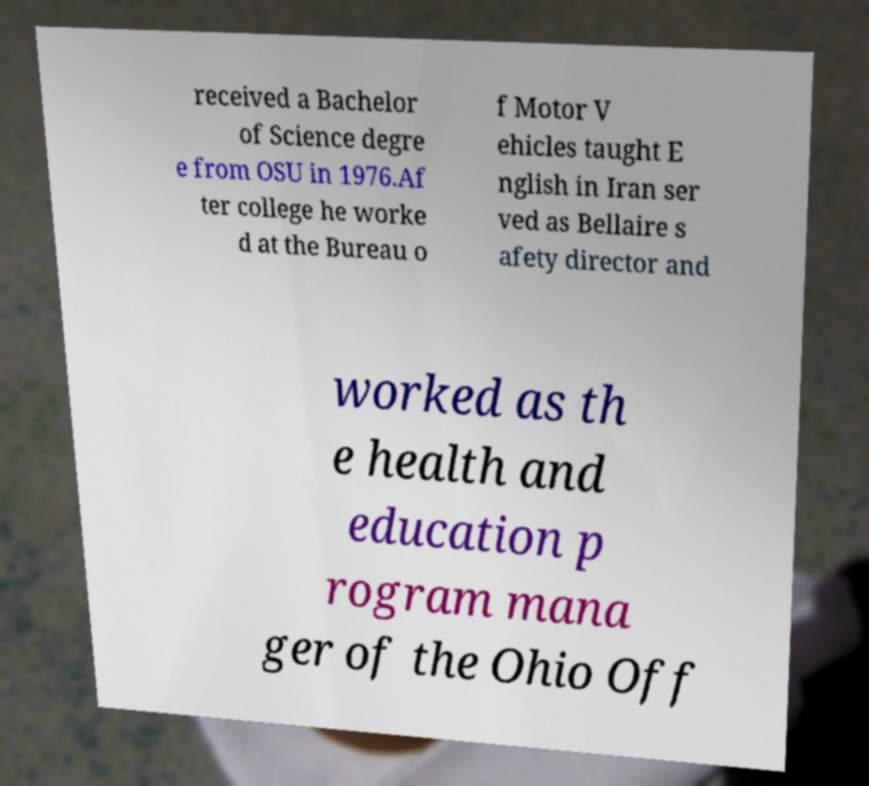Could you assist in decoding the text presented in this image and type it out clearly? received a Bachelor of Science degre e from OSU in 1976.Af ter college he worke d at the Bureau o f Motor V ehicles taught E nglish in Iran ser ved as Bellaire s afety director and worked as th e health and education p rogram mana ger of the Ohio Off 